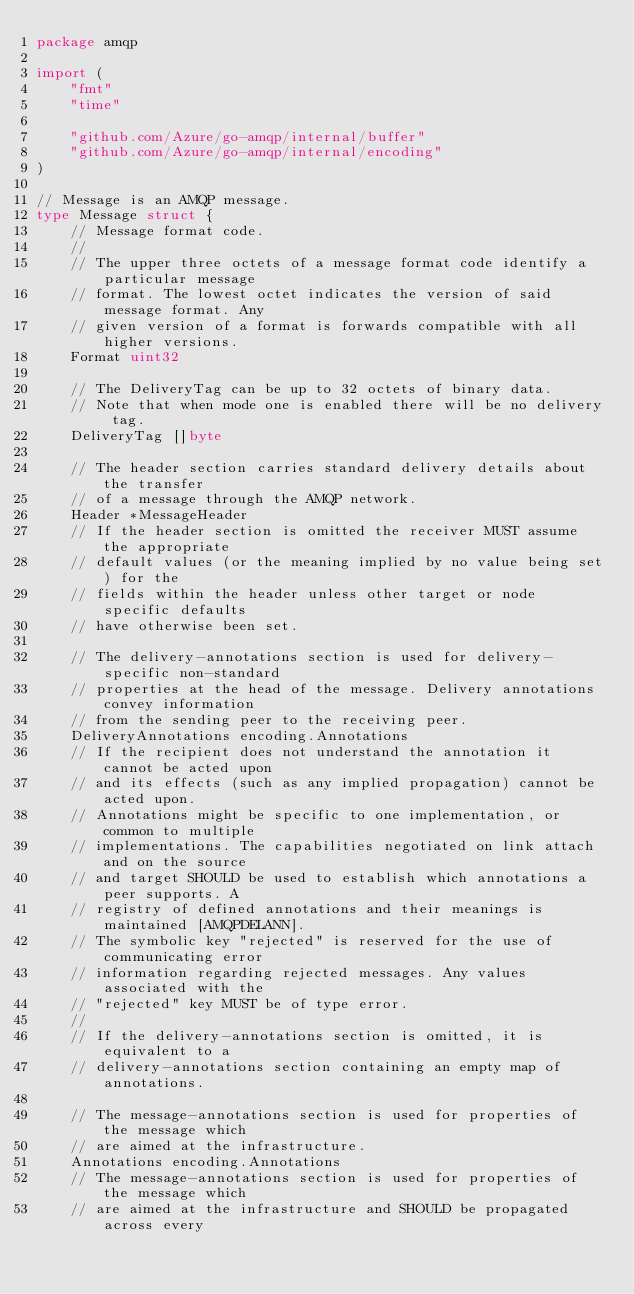<code> <loc_0><loc_0><loc_500><loc_500><_Go_>package amqp

import (
	"fmt"
	"time"

	"github.com/Azure/go-amqp/internal/buffer"
	"github.com/Azure/go-amqp/internal/encoding"
)

// Message is an AMQP message.
type Message struct {
	// Message format code.
	//
	// The upper three octets of a message format code identify a particular message
	// format. The lowest octet indicates the version of said message format. Any
	// given version of a format is forwards compatible with all higher versions.
	Format uint32

	// The DeliveryTag can be up to 32 octets of binary data.
	// Note that when mode one is enabled there will be no delivery tag.
	DeliveryTag []byte

	// The header section carries standard delivery details about the transfer
	// of a message through the AMQP network.
	Header *MessageHeader
	// If the header section is omitted the receiver MUST assume the appropriate
	// default values (or the meaning implied by no value being set) for the
	// fields within the header unless other target or node specific defaults
	// have otherwise been set.

	// The delivery-annotations section is used for delivery-specific non-standard
	// properties at the head of the message. Delivery annotations convey information
	// from the sending peer to the receiving peer.
	DeliveryAnnotations encoding.Annotations
	// If the recipient does not understand the annotation it cannot be acted upon
	// and its effects (such as any implied propagation) cannot be acted upon.
	// Annotations might be specific to one implementation, or common to multiple
	// implementations. The capabilities negotiated on link attach and on the source
	// and target SHOULD be used to establish which annotations a peer supports. A
	// registry of defined annotations and their meanings is maintained [AMQPDELANN].
	// The symbolic key "rejected" is reserved for the use of communicating error
	// information regarding rejected messages. Any values associated with the
	// "rejected" key MUST be of type error.
	//
	// If the delivery-annotations section is omitted, it is equivalent to a
	// delivery-annotations section containing an empty map of annotations.

	// The message-annotations section is used for properties of the message which
	// are aimed at the infrastructure.
	Annotations encoding.Annotations
	// The message-annotations section is used for properties of the message which
	// are aimed at the infrastructure and SHOULD be propagated across every</code> 